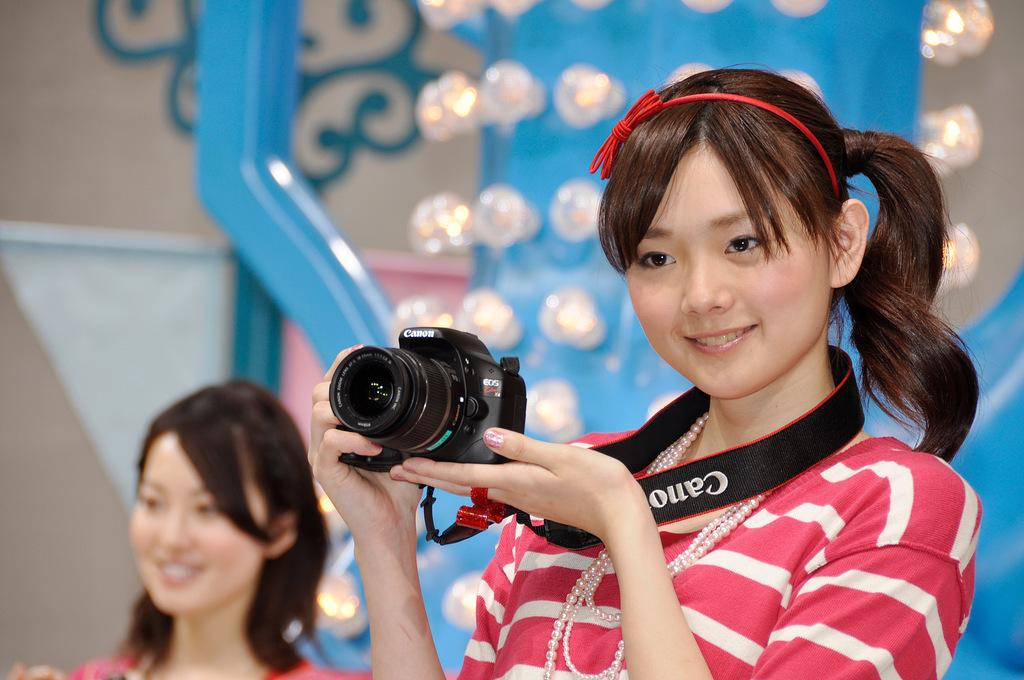What is the person in the image wearing? The person is wearing a red headband and dress in the image. What is the person holding in the image? The person is holding a camera. How is the other person in the image depicted? The other person is smiling in the image. What can be seen in the background of the image? There are lights visible in the background of the image. What is the name of the person holding the letter in the image? There is no letter present in the image, and therefore no name can be associated with it. 